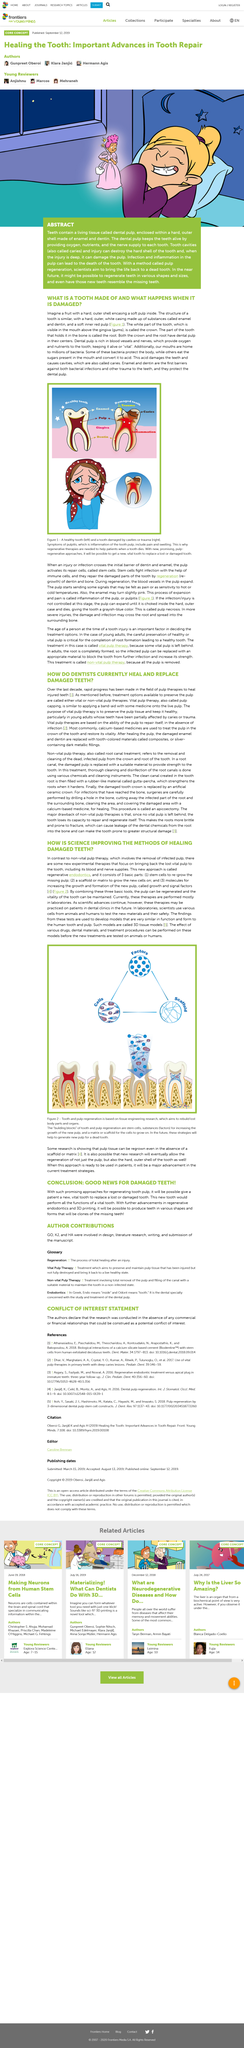Specify some key components in this picture. Treatment options are available to preserve the pulp, and they are called either vital or non-vital pulp therapies. Scientists are seeking to utilize a method called pulp regeneration in an attempt to restore lifeless teeth. Yes, calcium-based medicines are commonly used to treat the pulp in the crown of a tooth. This article is about the topic of teeth. The field of pulp therapies has made rapid progress in healing injured teeth over the last decade, as evidenced by the numerous advancements in this area. 